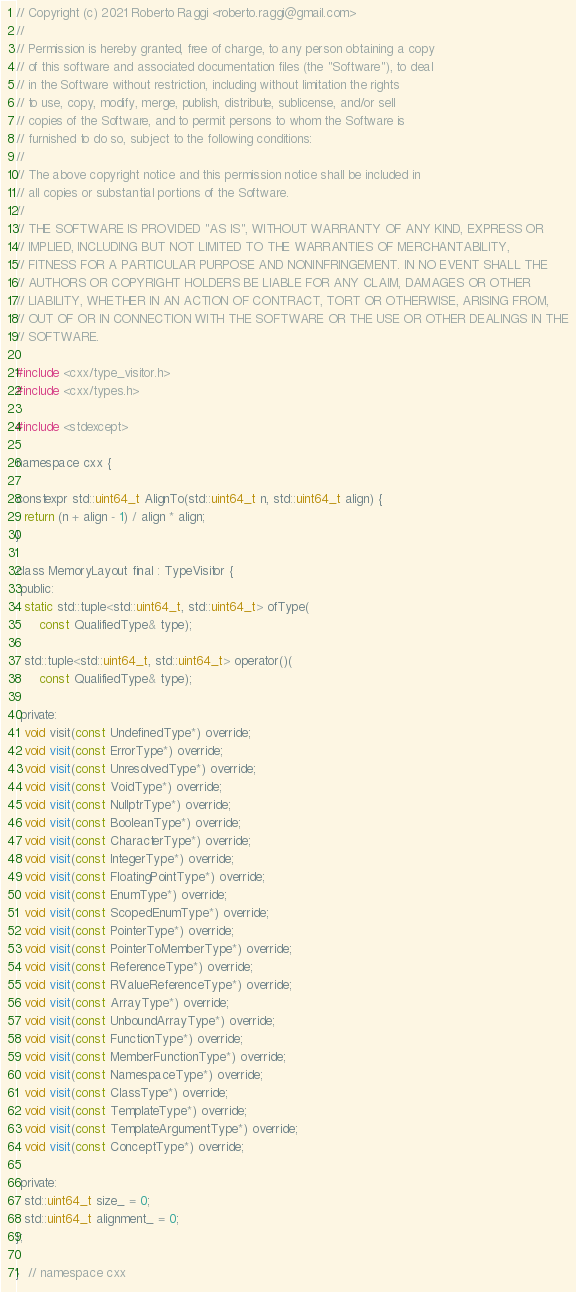Convert code to text. <code><loc_0><loc_0><loc_500><loc_500><_C_>// Copyright (c) 2021 Roberto Raggi <roberto.raggi@gmail.com>
//
// Permission is hereby granted, free of charge, to any person obtaining a copy
// of this software and associated documentation files (the "Software"), to deal
// in the Software without restriction, including without limitation the rights
// to use, copy, modify, merge, publish, distribute, sublicense, and/or sell
// copies of the Software, and to permit persons to whom the Software is
// furnished to do so, subject to the following conditions:
//
// The above copyright notice and this permission notice shall be included in
// all copies or substantial portions of the Software.
//
// THE SOFTWARE IS PROVIDED "AS IS", WITHOUT WARRANTY OF ANY KIND, EXPRESS OR
// IMPLIED, INCLUDING BUT NOT LIMITED TO THE WARRANTIES OF MERCHANTABILITY,
// FITNESS FOR A PARTICULAR PURPOSE AND NONINFRINGEMENT. IN NO EVENT SHALL THE
// AUTHORS OR COPYRIGHT HOLDERS BE LIABLE FOR ANY CLAIM, DAMAGES OR OTHER
// LIABILITY, WHETHER IN AN ACTION OF CONTRACT, TORT OR OTHERWISE, ARISING FROM,
// OUT OF OR IN CONNECTION WITH THE SOFTWARE OR THE USE OR OTHER DEALINGS IN THE
// SOFTWARE.

#include <cxx/type_visitor.h>
#include <cxx/types.h>

#include <stdexcept>

namespace cxx {

constexpr std::uint64_t AlignTo(std::uint64_t n, std::uint64_t align) {
  return (n + align - 1) / align * align;
}

class MemoryLayout final : TypeVisitor {
 public:
  static std::tuple<std::uint64_t, std::uint64_t> ofType(
      const QualifiedType& type);

  std::tuple<std::uint64_t, std::uint64_t> operator()(
      const QualifiedType& type);

 private:
  void visit(const UndefinedType*) override;
  void visit(const ErrorType*) override;
  void visit(const UnresolvedType*) override;
  void visit(const VoidType*) override;
  void visit(const NullptrType*) override;
  void visit(const BooleanType*) override;
  void visit(const CharacterType*) override;
  void visit(const IntegerType*) override;
  void visit(const FloatingPointType*) override;
  void visit(const EnumType*) override;
  void visit(const ScopedEnumType*) override;
  void visit(const PointerType*) override;
  void visit(const PointerToMemberType*) override;
  void visit(const ReferenceType*) override;
  void visit(const RValueReferenceType*) override;
  void visit(const ArrayType*) override;
  void visit(const UnboundArrayType*) override;
  void visit(const FunctionType*) override;
  void visit(const MemberFunctionType*) override;
  void visit(const NamespaceType*) override;
  void visit(const ClassType*) override;
  void visit(const TemplateType*) override;
  void visit(const TemplateArgumentType*) override;
  void visit(const ConceptType*) override;

 private:
  std::uint64_t size_ = 0;
  std::uint64_t alignment_ = 0;
};

}  // namespace cxx
</code> 